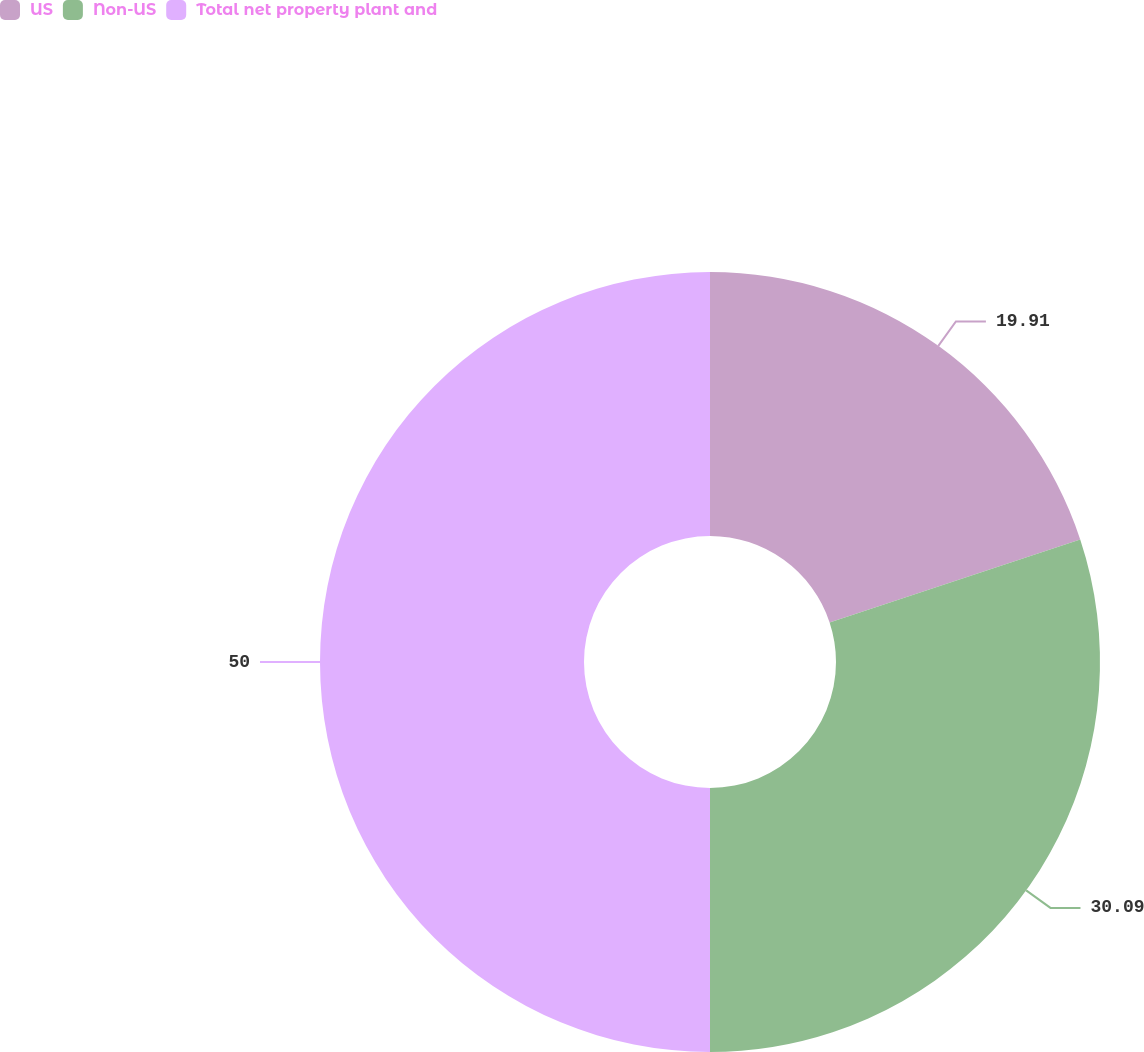<chart> <loc_0><loc_0><loc_500><loc_500><pie_chart><fcel>US<fcel>Non-US<fcel>Total net property plant and<nl><fcel>19.91%<fcel>30.09%<fcel>50.0%<nl></chart> 